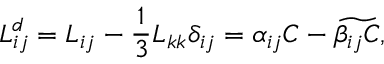Convert formula to latex. <formula><loc_0><loc_0><loc_500><loc_500>L _ { i j } ^ { d } = L _ { i j } - \frac { 1 } { 3 } L _ { k k } \delta _ { i j } = \alpha _ { i j } C - \widetilde { \beta _ { i j } C } ,</formula> 